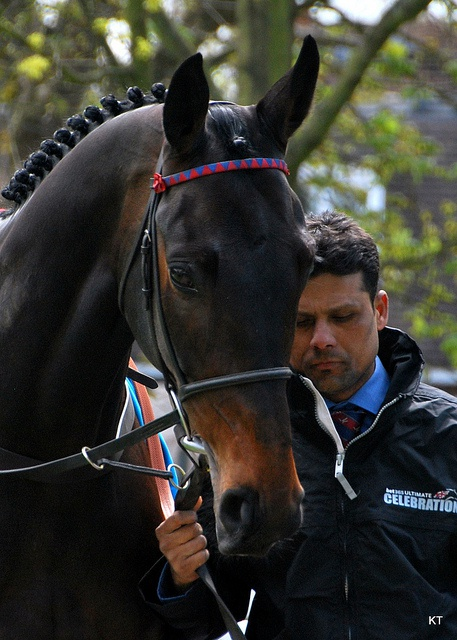Describe the objects in this image and their specific colors. I can see horse in black, gray, and maroon tones, people in black, gray, maroon, and brown tones, and tie in black, maroon, gray, and navy tones in this image. 